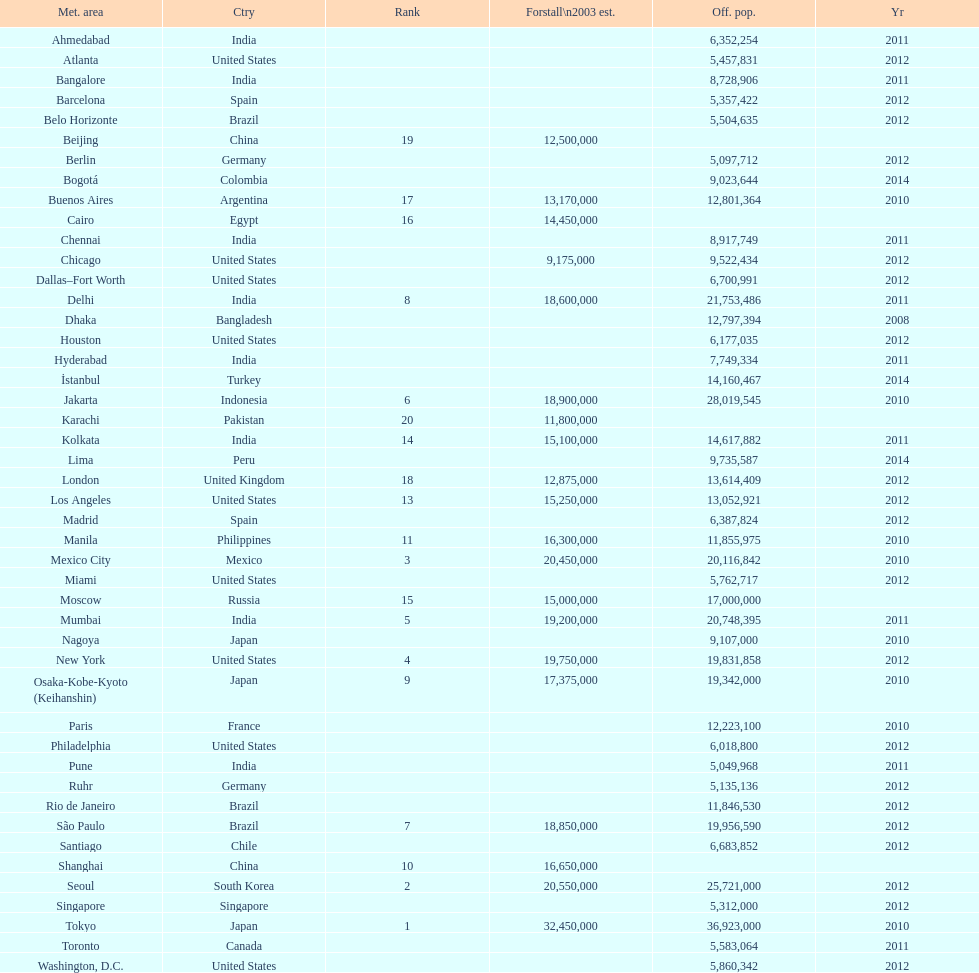Name a city from the same country as bangalore. Ahmedabad. 